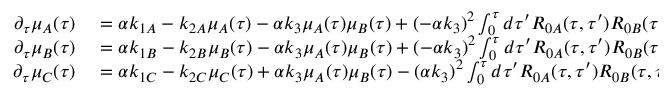Convert formula to latex. <formula><loc_0><loc_0><loc_500><loc_500>\begin{array} { r l } { \partial _ { \tau } \mu _ { A } ( \tau ) } & = \alpha k _ { 1 A } - k _ { 2 A } \mu _ { A } ( \tau ) - \alpha k _ { 3 } \mu _ { A } ( \tau ) \mu _ { B } ( \tau ) + ( - \alpha k _ { 3 } ) ^ { 2 } \int _ { 0 } ^ { \tau } d \tau ^ { \prime } R _ { 0 A } ( \tau , \tau ^ { \prime } ) R _ { 0 B } ( \tau , \tau ^ { \prime } ) \mu _ { A } ( \tau ^ { \prime } ) \mu _ { B } ( \tau ^ { \prime } ) } \\ { \partial _ { \tau } \mu _ { B } ( \tau ) } & = \alpha k _ { 1 B } - k _ { 2 B } \mu _ { B } ( \tau ) - \alpha k _ { 3 } \mu _ { A } ( \tau ) \mu _ { B } ( \tau ) + ( - \alpha k _ { 3 } ) ^ { 2 } \int _ { 0 } ^ { \tau } d \tau ^ { \prime } R _ { 0 A } ( \tau , \tau ^ { \prime } ) R _ { 0 B } ( \tau , \tau ^ { \prime } ) \mu _ { A } ( \tau ^ { \prime } ) \mu _ { B } ( \tau ^ { \prime } ) } \\ { \partial _ { \tau } \mu _ { C } ( \tau ) } & = \alpha k _ { 1 C } - k _ { 2 C } \mu _ { C } ( \tau ) + \alpha k _ { 3 } \mu _ { A } ( \tau ) \mu _ { B } ( \tau ) - ( \alpha k _ { 3 } ) ^ { 2 } \int _ { 0 } ^ { \tau } d \tau ^ { \prime } R _ { 0 A } ( \tau , \tau ^ { \prime } ) R _ { 0 B } ( \tau , \tau ^ { \prime } ) \mu _ { A } ( \tau ^ { \prime } ) \mu _ { B } ( \tau ^ { \prime } ) } \end{array}</formula> 